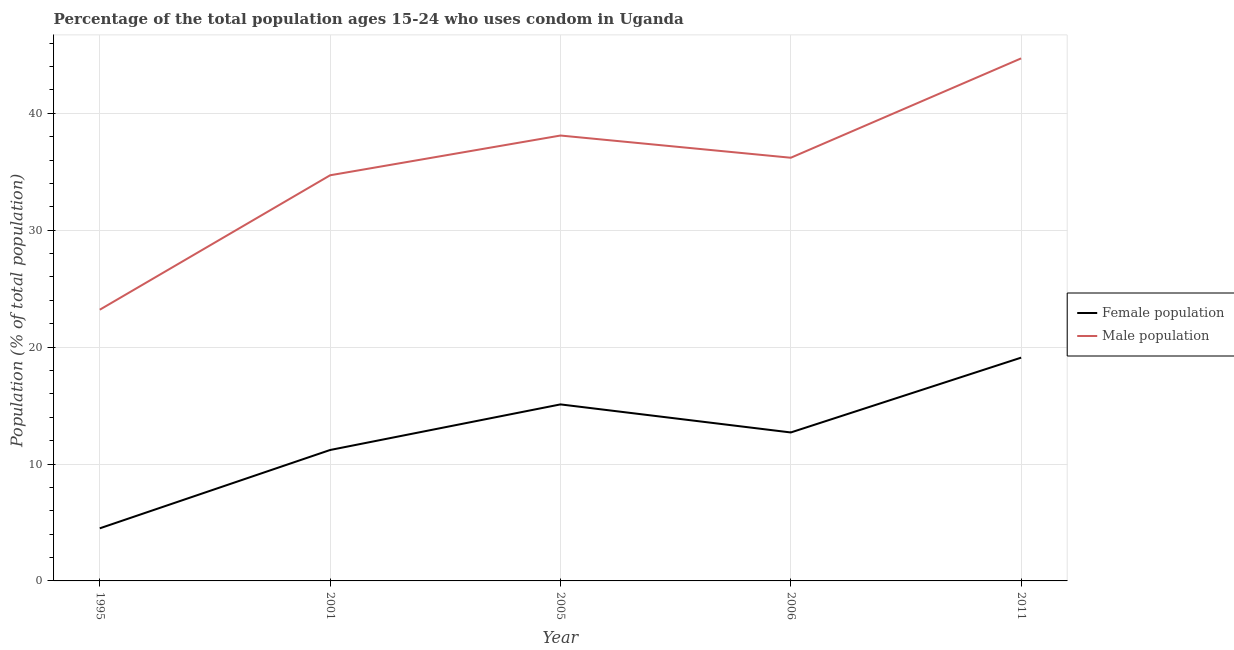Across all years, what is the maximum male population?
Provide a short and direct response. 44.7. Across all years, what is the minimum male population?
Provide a short and direct response. 23.2. What is the total female population in the graph?
Your answer should be very brief. 62.6. What is the difference between the male population in 2005 and that in 2006?
Offer a terse response. 1.9. What is the difference between the female population in 2006 and the male population in 1995?
Provide a succinct answer. -10.5. What is the average male population per year?
Provide a short and direct response. 35.38. In the year 1995, what is the difference between the male population and female population?
Keep it short and to the point. 18.7. What is the ratio of the male population in 2001 to that in 2011?
Your answer should be very brief. 0.78. Is the male population in 1995 less than that in 2005?
Your answer should be compact. Yes. Is the difference between the female population in 1995 and 2005 greater than the difference between the male population in 1995 and 2005?
Make the answer very short. Yes. What is the difference between the highest and the second highest male population?
Ensure brevity in your answer.  6.6. What is the difference between the highest and the lowest male population?
Make the answer very short. 21.5. Is the female population strictly greater than the male population over the years?
Give a very brief answer. No. How many years are there in the graph?
Your response must be concise. 5. What is the difference between two consecutive major ticks on the Y-axis?
Ensure brevity in your answer.  10. Are the values on the major ticks of Y-axis written in scientific E-notation?
Keep it short and to the point. No. Does the graph contain any zero values?
Make the answer very short. No. Does the graph contain grids?
Offer a very short reply. Yes. Where does the legend appear in the graph?
Your response must be concise. Center right. How are the legend labels stacked?
Provide a short and direct response. Vertical. What is the title of the graph?
Provide a short and direct response. Percentage of the total population ages 15-24 who uses condom in Uganda. What is the label or title of the Y-axis?
Your answer should be very brief. Population (% of total population) . What is the Population (% of total population)  in Female population in 1995?
Offer a terse response. 4.5. What is the Population (% of total population)  of Male population in 1995?
Provide a short and direct response. 23.2. What is the Population (% of total population)  of Female population in 2001?
Keep it short and to the point. 11.2. What is the Population (% of total population)  of Male population in 2001?
Offer a very short reply. 34.7. What is the Population (% of total population)  of Male population in 2005?
Provide a short and direct response. 38.1. What is the Population (% of total population)  in Male population in 2006?
Make the answer very short. 36.2. What is the Population (% of total population)  of Male population in 2011?
Provide a short and direct response. 44.7. Across all years, what is the maximum Population (% of total population)  in Male population?
Make the answer very short. 44.7. Across all years, what is the minimum Population (% of total population)  in Male population?
Offer a terse response. 23.2. What is the total Population (% of total population)  in Female population in the graph?
Your answer should be compact. 62.6. What is the total Population (% of total population)  in Male population in the graph?
Ensure brevity in your answer.  176.9. What is the difference between the Population (% of total population)  in Male population in 1995 and that in 2001?
Your response must be concise. -11.5. What is the difference between the Population (% of total population)  in Male population in 1995 and that in 2005?
Offer a very short reply. -14.9. What is the difference between the Population (% of total population)  in Male population in 1995 and that in 2006?
Provide a succinct answer. -13. What is the difference between the Population (% of total population)  of Female population in 1995 and that in 2011?
Give a very brief answer. -14.6. What is the difference between the Population (% of total population)  in Male population in 1995 and that in 2011?
Your response must be concise. -21.5. What is the difference between the Population (% of total population)  of Female population in 2001 and that in 2005?
Keep it short and to the point. -3.9. What is the difference between the Population (% of total population)  in Female population in 2001 and that in 2011?
Keep it short and to the point. -7.9. What is the difference between the Population (% of total population)  of Male population in 2001 and that in 2011?
Give a very brief answer. -10. What is the difference between the Population (% of total population)  of Male population in 2005 and that in 2006?
Provide a short and direct response. 1.9. What is the difference between the Population (% of total population)  of Female population in 2005 and that in 2011?
Ensure brevity in your answer.  -4. What is the difference between the Population (% of total population)  in Male population in 2005 and that in 2011?
Ensure brevity in your answer.  -6.6. What is the difference between the Population (% of total population)  of Female population in 2006 and that in 2011?
Provide a short and direct response. -6.4. What is the difference between the Population (% of total population)  of Female population in 1995 and the Population (% of total population)  of Male population in 2001?
Give a very brief answer. -30.2. What is the difference between the Population (% of total population)  in Female population in 1995 and the Population (% of total population)  in Male population in 2005?
Your response must be concise. -33.6. What is the difference between the Population (% of total population)  in Female population in 1995 and the Population (% of total population)  in Male population in 2006?
Make the answer very short. -31.7. What is the difference between the Population (% of total population)  of Female population in 1995 and the Population (% of total population)  of Male population in 2011?
Your answer should be very brief. -40.2. What is the difference between the Population (% of total population)  of Female population in 2001 and the Population (% of total population)  of Male population in 2005?
Your answer should be very brief. -26.9. What is the difference between the Population (% of total population)  of Female population in 2001 and the Population (% of total population)  of Male population in 2011?
Offer a very short reply. -33.5. What is the difference between the Population (% of total population)  in Female population in 2005 and the Population (% of total population)  in Male population in 2006?
Provide a short and direct response. -21.1. What is the difference between the Population (% of total population)  in Female population in 2005 and the Population (% of total population)  in Male population in 2011?
Your answer should be very brief. -29.6. What is the difference between the Population (% of total population)  in Female population in 2006 and the Population (% of total population)  in Male population in 2011?
Offer a very short reply. -32. What is the average Population (% of total population)  in Female population per year?
Keep it short and to the point. 12.52. What is the average Population (% of total population)  in Male population per year?
Provide a succinct answer. 35.38. In the year 1995, what is the difference between the Population (% of total population)  in Female population and Population (% of total population)  in Male population?
Ensure brevity in your answer.  -18.7. In the year 2001, what is the difference between the Population (% of total population)  in Female population and Population (% of total population)  in Male population?
Ensure brevity in your answer.  -23.5. In the year 2005, what is the difference between the Population (% of total population)  of Female population and Population (% of total population)  of Male population?
Provide a succinct answer. -23. In the year 2006, what is the difference between the Population (% of total population)  in Female population and Population (% of total population)  in Male population?
Your answer should be compact. -23.5. In the year 2011, what is the difference between the Population (% of total population)  in Female population and Population (% of total population)  in Male population?
Offer a very short reply. -25.6. What is the ratio of the Population (% of total population)  in Female population in 1995 to that in 2001?
Your response must be concise. 0.4. What is the ratio of the Population (% of total population)  in Male population in 1995 to that in 2001?
Make the answer very short. 0.67. What is the ratio of the Population (% of total population)  in Female population in 1995 to that in 2005?
Ensure brevity in your answer.  0.3. What is the ratio of the Population (% of total population)  in Male population in 1995 to that in 2005?
Offer a terse response. 0.61. What is the ratio of the Population (% of total population)  in Female population in 1995 to that in 2006?
Offer a very short reply. 0.35. What is the ratio of the Population (% of total population)  of Male population in 1995 to that in 2006?
Your response must be concise. 0.64. What is the ratio of the Population (% of total population)  of Female population in 1995 to that in 2011?
Ensure brevity in your answer.  0.24. What is the ratio of the Population (% of total population)  in Male population in 1995 to that in 2011?
Provide a short and direct response. 0.52. What is the ratio of the Population (% of total population)  of Female population in 2001 to that in 2005?
Your answer should be compact. 0.74. What is the ratio of the Population (% of total population)  in Male population in 2001 to that in 2005?
Your answer should be compact. 0.91. What is the ratio of the Population (% of total population)  of Female population in 2001 to that in 2006?
Keep it short and to the point. 0.88. What is the ratio of the Population (% of total population)  in Male population in 2001 to that in 2006?
Your response must be concise. 0.96. What is the ratio of the Population (% of total population)  of Female population in 2001 to that in 2011?
Your answer should be very brief. 0.59. What is the ratio of the Population (% of total population)  of Male population in 2001 to that in 2011?
Your answer should be very brief. 0.78. What is the ratio of the Population (% of total population)  of Female population in 2005 to that in 2006?
Provide a short and direct response. 1.19. What is the ratio of the Population (% of total population)  of Male population in 2005 to that in 2006?
Your response must be concise. 1.05. What is the ratio of the Population (% of total population)  of Female population in 2005 to that in 2011?
Give a very brief answer. 0.79. What is the ratio of the Population (% of total population)  of Male population in 2005 to that in 2011?
Keep it short and to the point. 0.85. What is the ratio of the Population (% of total population)  of Female population in 2006 to that in 2011?
Your answer should be very brief. 0.66. What is the ratio of the Population (% of total population)  in Male population in 2006 to that in 2011?
Ensure brevity in your answer.  0.81. What is the difference between the highest and the second highest Population (% of total population)  of Female population?
Your response must be concise. 4. What is the difference between the highest and the second highest Population (% of total population)  in Male population?
Your answer should be very brief. 6.6. What is the difference between the highest and the lowest Population (% of total population)  of Male population?
Offer a terse response. 21.5. 